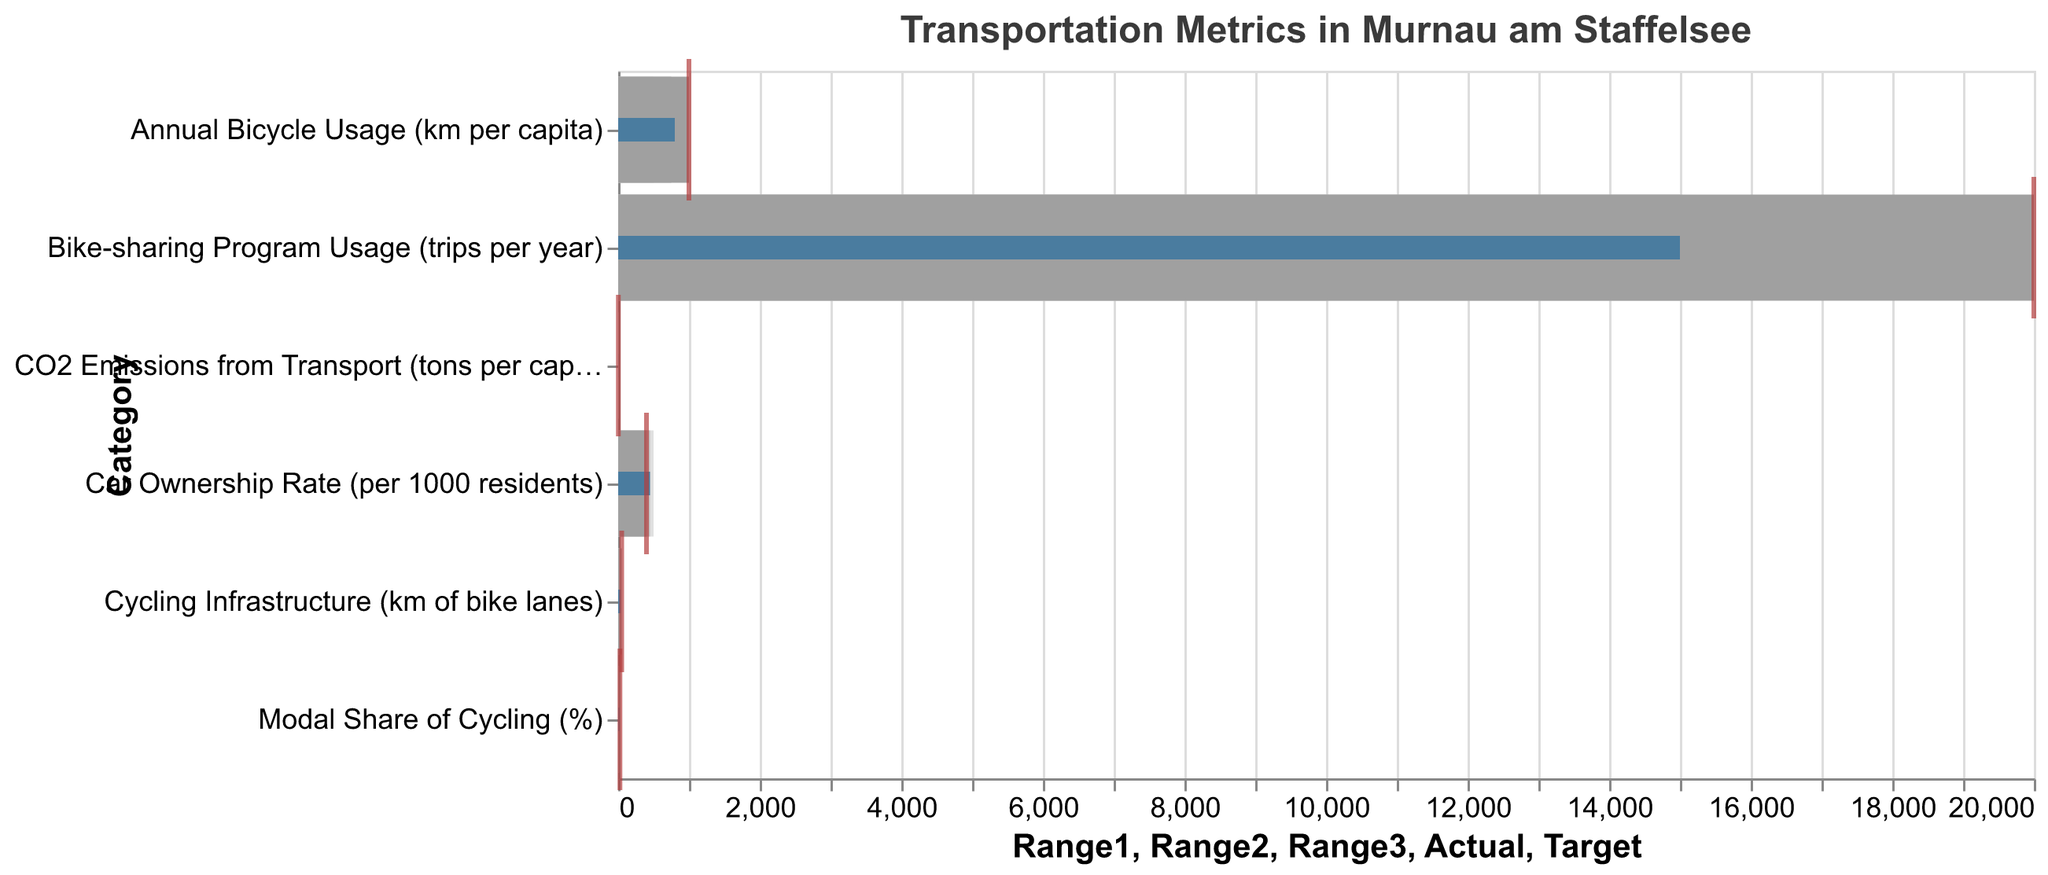What's the title of the figure? The title of the figure is written at the top center and provides an overview of what the chart is about.
Answer: Transportation Metrics in Murnau am Staffelsee What are the target values for 'Annual Bicycle Usage' and 'Car Ownership Rate'? Refer to the ticks marked in red placed on the horizontal axis for these categories. For 'Annual Bicycle Usage,' it's 1000, and for 'Car Ownership Rate,' it's 400.
Answer: 1000 and 400 What is the actual value for CO2 emissions from transport? Look at the blue bar representing the actual value for 'CO2 Emissions from Transport (tons per capita)'. It is positioned at 2.5.
Answer: 2.5 How much is the 'Modal Share of Cycling' below its target? The target value for 'Modal Share of Cycling (%)' is 25. The actual value is represented by the blue bar at 18. The difference is 25 - 18 = 7.
Answer: 7 Compare the actual 'Cycling Infrastructure' to its target. Is it above or below the target? The target for 'Cycling Infrastructure (km of bike lanes)' is 50, advised by the red tick. The actual value is represented by the blue bar at 35. The actual value is below the target.
Answer: below the target Across which categories have the targets been met or exceeded? Compare the red tick (target) and blue bar (actual) across all categories. Only 'CO2 Emissions from Transport' has met or exceeded the target (actual = 2.5, target = 2).
Answer: CO2 Emissions from Transport How does the 'Bike-sharing Program Usage' actual value compare to the 'Cycling Infrastructure' actual value? The actual value for the 'Bike-sharing Program Usage (trips per year)' is 15000 trips, and for 'Cycling Infrastructure (km of bike lanes),' it is 35 km. They measure different things, but in actual and target comparison, 'Bike-sharing Program Usage' did not meet the target.
Answer: Bike-sharing Program Usage did not meet the target Among all categories, which has the highest actual value? Observe the blue bars that represent the actual values and find the longest bar. The 'Bike-sharing Program Usage' has the highest actual value at 15000 trips per year.
Answer: Bike-sharing Program Usage How far is the actual 'Car Ownership Rate' from being within its target range? The target range maximum for 'Car Ownership Rate (per 1000 residents)' is 400. The actual rate is at 450, which is 50 above the target range maximum.
Answer: 50 above the target range 